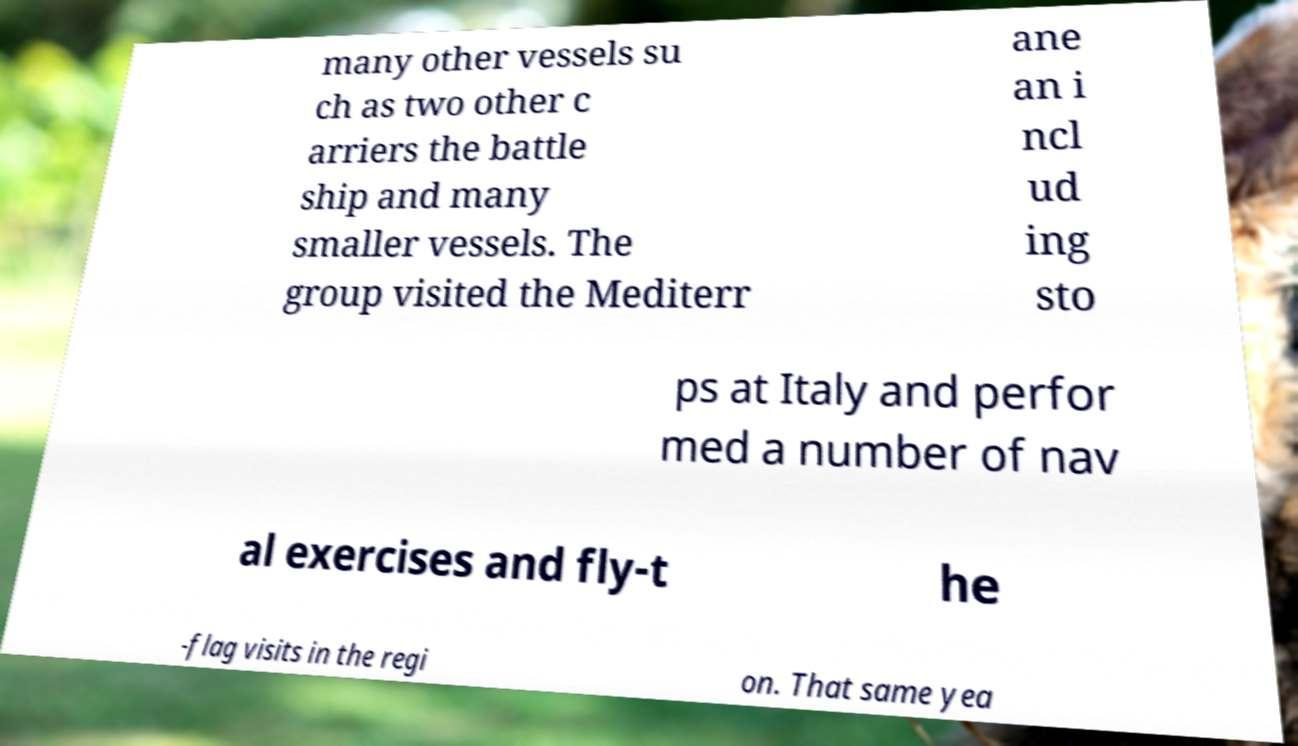Can you read and provide the text displayed in the image?This photo seems to have some interesting text. Can you extract and type it out for me? many other vessels su ch as two other c arriers the battle ship and many smaller vessels. The group visited the Mediterr ane an i ncl ud ing sto ps at Italy and perfor med a number of nav al exercises and fly-t he -flag visits in the regi on. That same yea 